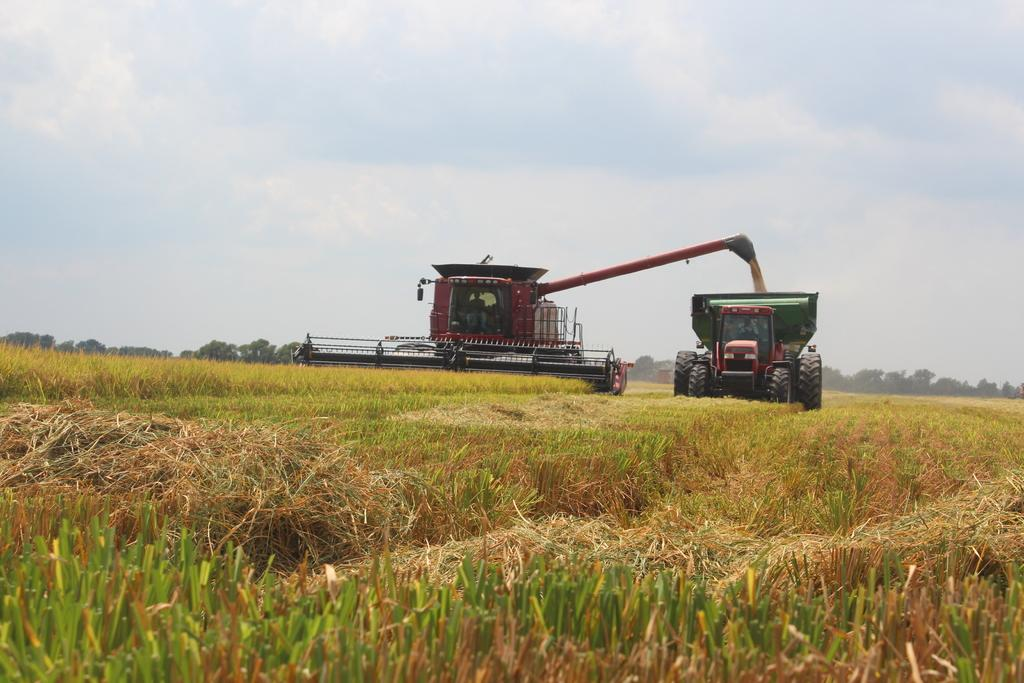What is the main subject of the image? The main subject of the image is a harvesting cutting machine. What is present on the surface at the bottom of the image? There is grass on the surface at the bottom of the image. What can be seen in the background of the image? There are trees and the sky visible in the background of the image. How old is the baby celebrating their birthday in the image? There is no baby or birthday celebration present in the image; it features a harvesting cutting machine and grass. What type of cheese is the rat eating in the image? There is no rat present in the image, so it cannot be determined what type of cheese it might be eating. 